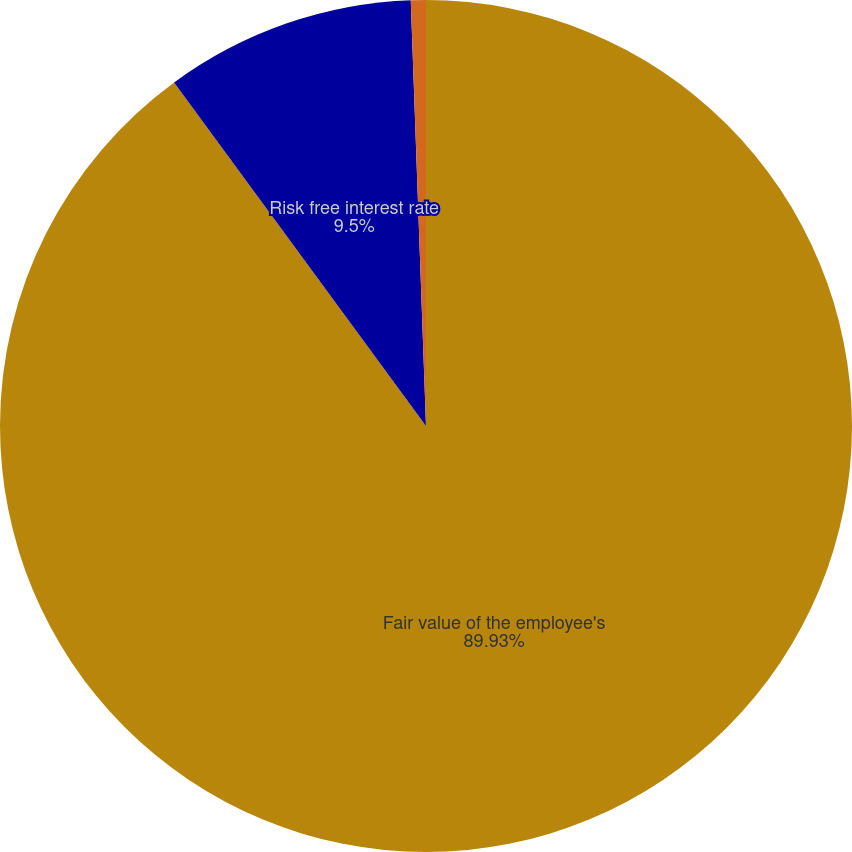<chart> <loc_0><loc_0><loc_500><loc_500><pie_chart><fcel>Fair value of the employee's<fcel>Risk free interest rate<fcel>Expected volatility<nl><fcel>89.93%<fcel>9.5%<fcel>0.57%<nl></chart> 